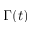Convert formula to latex. <formula><loc_0><loc_0><loc_500><loc_500>\Gamma ( t )</formula> 